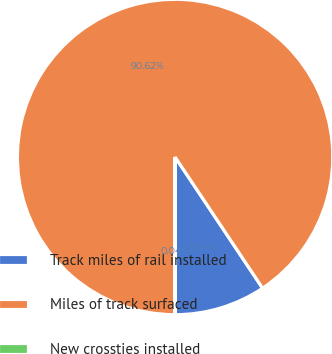Convert chart. <chart><loc_0><loc_0><loc_500><loc_500><pie_chart><fcel>Track miles of rail installed<fcel>Miles of track surfaced<fcel>New crossties installed<nl><fcel>9.34%<fcel>90.62%<fcel>0.04%<nl></chart> 